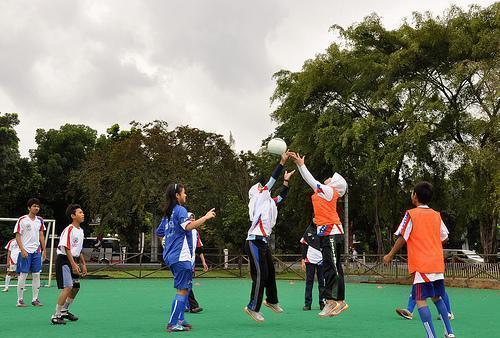How many balls are seen?
Give a very brief answer. 1. 